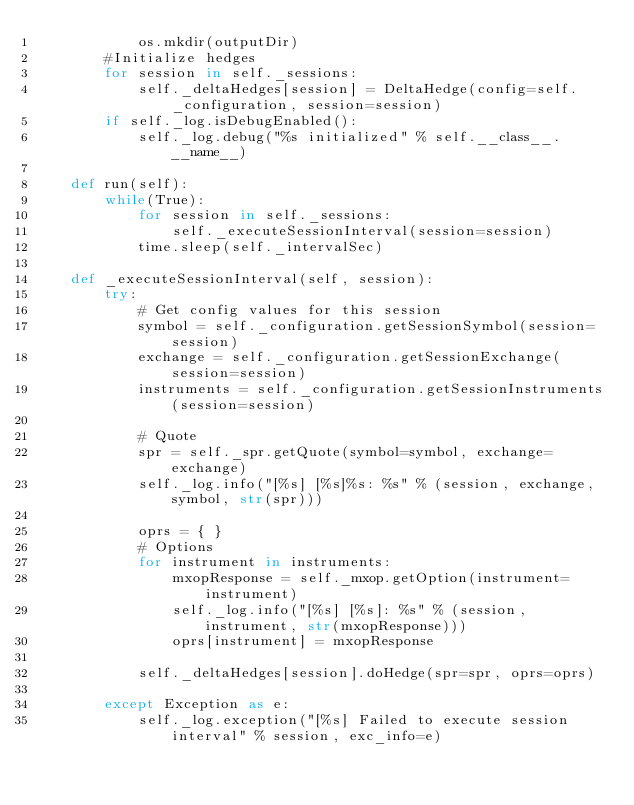<code> <loc_0><loc_0><loc_500><loc_500><_Python_>            os.mkdir(outputDir)
        #Initialize hedges
        for session in self._sessions:
            self._deltaHedges[session] = DeltaHedge(config=self._configuration, session=session)
        if self._log.isDebugEnabled():
            self._log.debug("%s initialized" % self.__class__.__name__)
    
    def run(self):
        while(True):
            for session in self._sessions:
                self._executeSessionInterval(session=session)
            time.sleep(self._intervalSec)
            
    def _executeSessionInterval(self, session):
        try:
            # Get config values for this session
            symbol = self._configuration.getSessionSymbol(session=session)
            exchange = self._configuration.getSessionExchange(session=session)
            instruments = self._configuration.getSessionInstruments(session=session)

            # Quote
            spr = self._spr.getQuote(symbol=symbol, exchange=exchange)
            self._log.info("[%s] [%s]%s: %s" % (session, exchange, symbol, str(spr)))
            
            oprs = { }
            # Options
            for instrument in instruments:
                mxopResponse = self._mxop.getOption(instrument=instrument)
                self._log.info("[%s] [%s]: %s" % (session, instrument, str(mxopResponse)))
                oprs[instrument] = mxopResponse
            
            self._deltaHedges[session].doHedge(spr=spr, oprs=oprs)
            
        except Exception as e:
            self._log.exception("[%s] Failed to execute session interval" % session, exc_info=e)</code> 